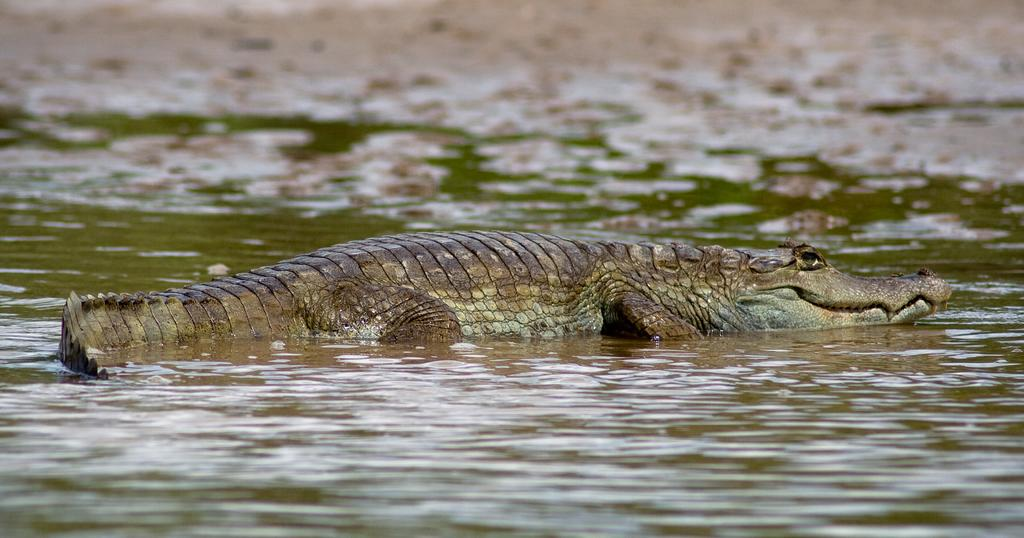What is the main subject in the center of the image? There is a crocodile in the center of the image. Where is the crocodile located? The crocodile is in the water. What can be seen in the image besides the crocodile? There is water visible in the image. What type of lamp is hanging above the crocodile in the image? There is no lamp present in the image; it features a crocodile in the water. How does the crocodile generate profit in the image? The image does not depict any profit-generating activities involving the crocodile. 